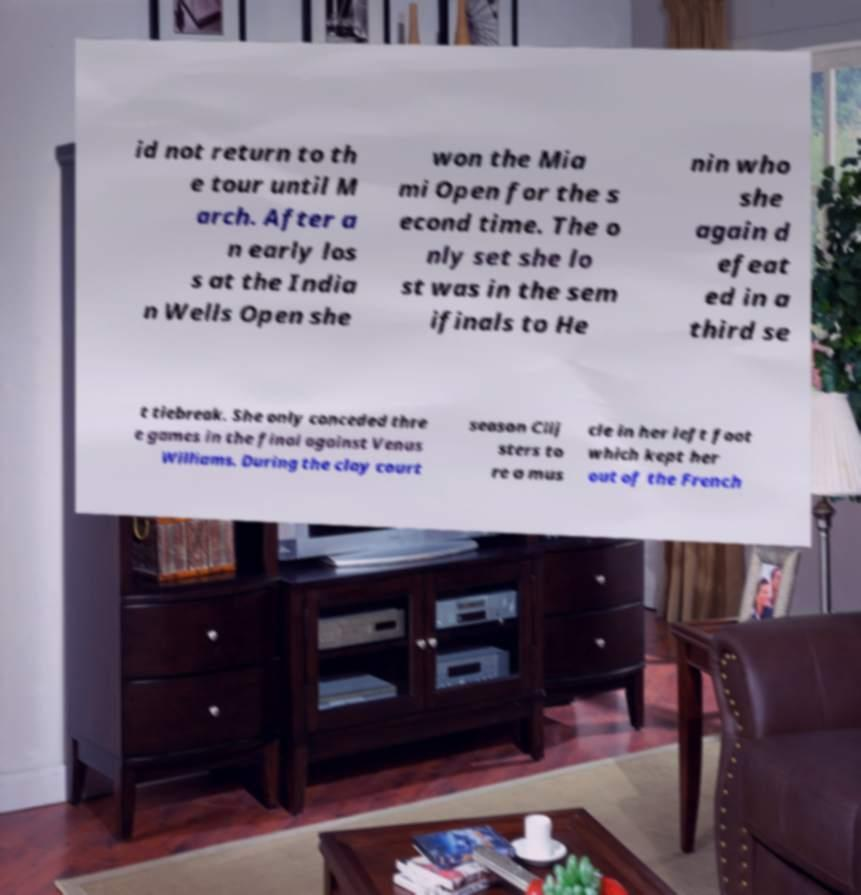Please identify and transcribe the text found in this image. id not return to th e tour until M arch. After a n early los s at the India n Wells Open she won the Mia mi Open for the s econd time. The o nly set she lo st was in the sem ifinals to He nin who she again d efeat ed in a third se t tiebreak. She only conceded thre e games in the final against Venus Williams. During the clay court season Clij sters to re a mus cle in her left foot which kept her out of the French 